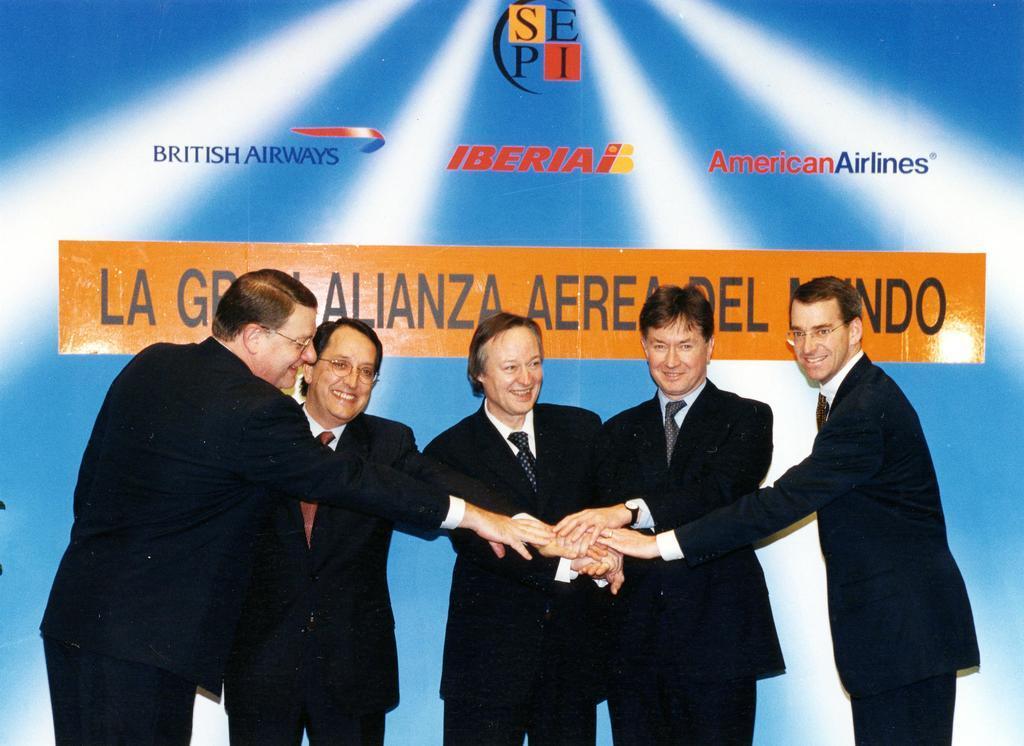Please provide a concise description of this image. In the background we can see a hoarding. Here we can see few men standing. Among them there are wearing spectacles and all are smiling. 